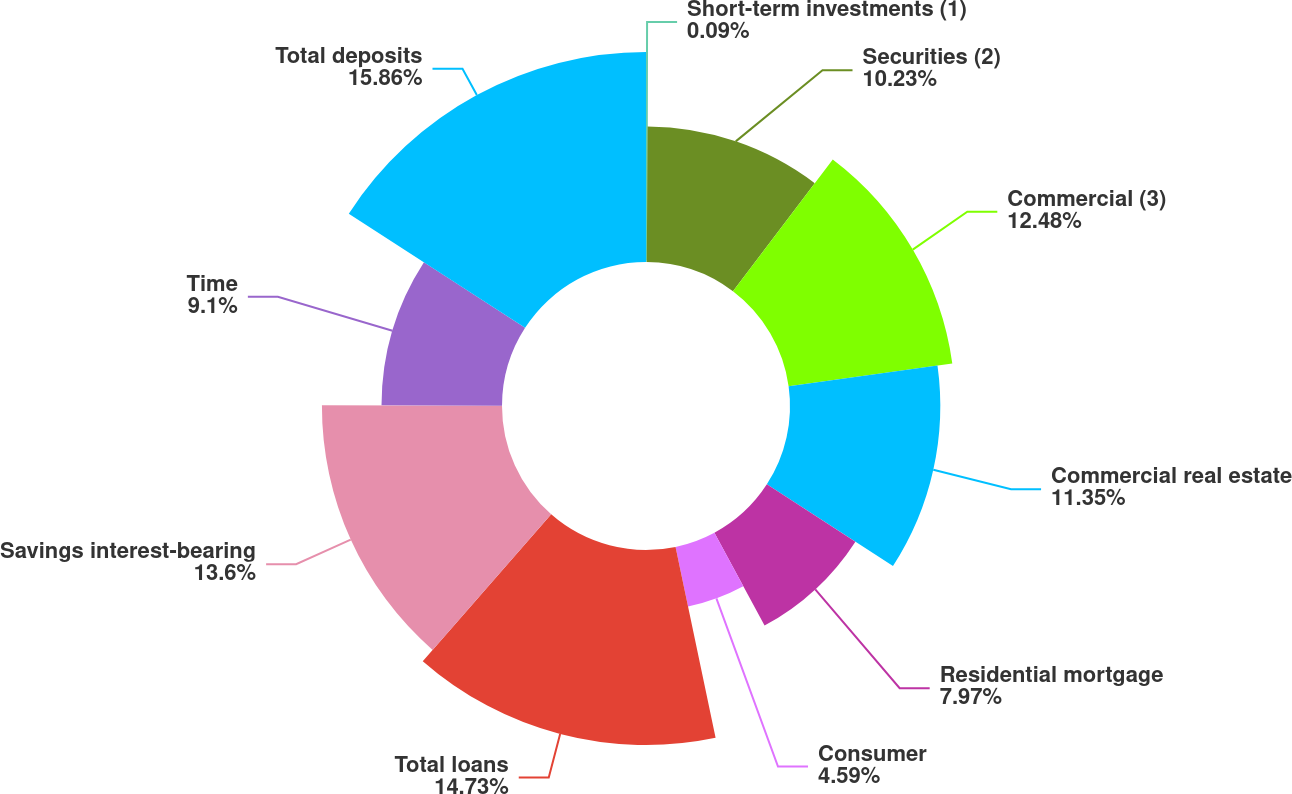Convert chart. <chart><loc_0><loc_0><loc_500><loc_500><pie_chart><fcel>Short-term investments (1)<fcel>Securities (2)<fcel>Commercial (3)<fcel>Commercial real estate<fcel>Residential mortgage<fcel>Consumer<fcel>Total loans<fcel>Savings interest-bearing<fcel>Time<fcel>Total deposits<nl><fcel>0.09%<fcel>10.23%<fcel>12.48%<fcel>11.35%<fcel>7.97%<fcel>4.59%<fcel>14.73%<fcel>13.6%<fcel>9.1%<fcel>15.86%<nl></chart> 